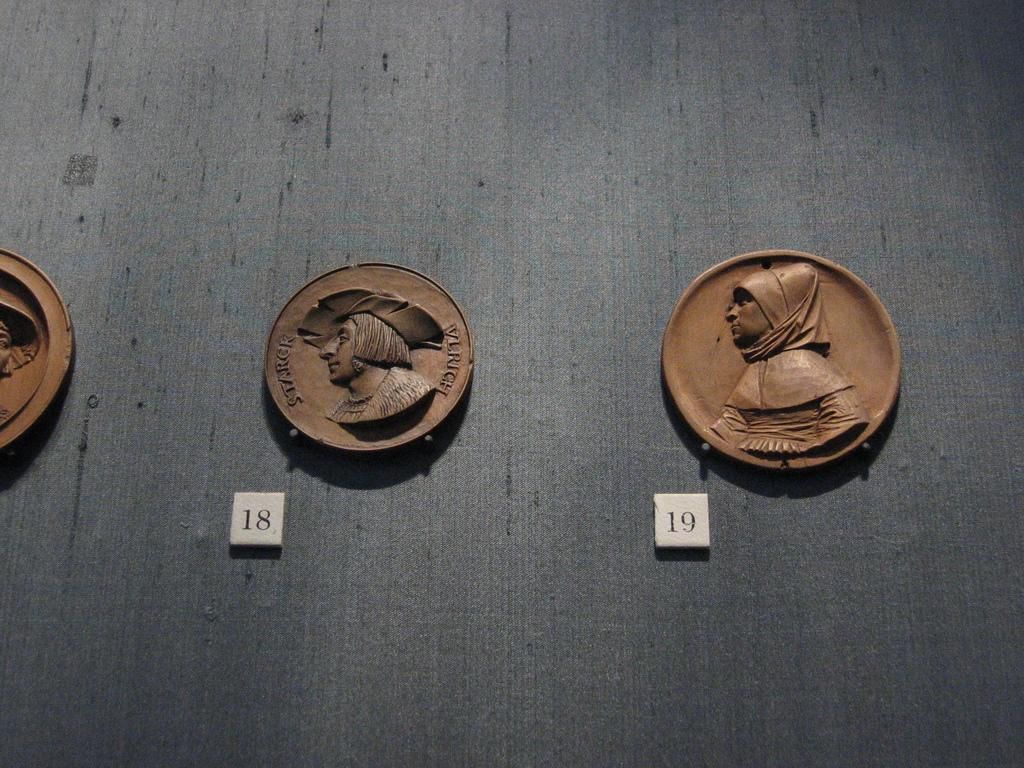<image>
Render a clear and concise summary of the photo. The coin has a paper with the number 19 next to it 